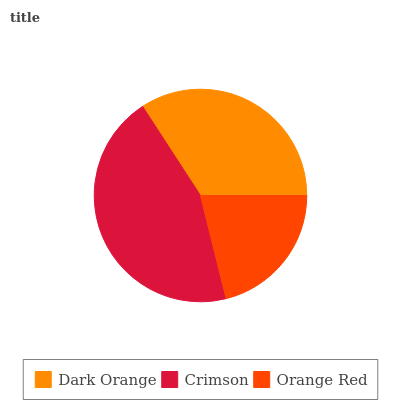Is Orange Red the minimum?
Answer yes or no. Yes. Is Crimson the maximum?
Answer yes or no. Yes. Is Crimson the minimum?
Answer yes or no. No. Is Orange Red the maximum?
Answer yes or no. No. Is Crimson greater than Orange Red?
Answer yes or no. Yes. Is Orange Red less than Crimson?
Answer yes or no. Yes. Is Orange Red greater than Crimson?
Answer yes or no. No. Is Crimson less than Orange Red?
Answer yes or no. No. Is Dark Orange the high median?
Answer yes or no. Yes. Is Dark Orange the low median?
Answer yes or no. Yes. Is Crimson the high median?
Answer yes or no. No. Is Orange Red the low median?
Answer yes or no. No. 